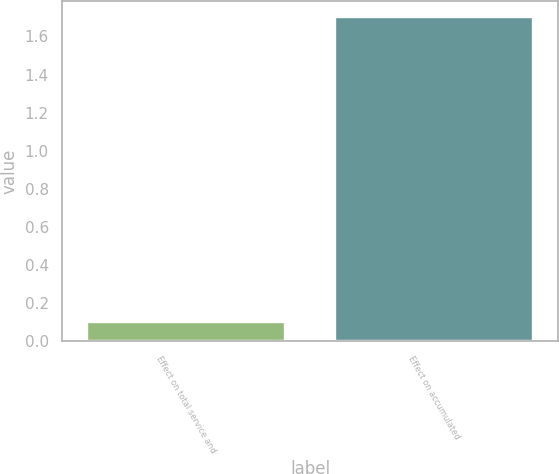Convert chart. <chart><loc_0><loc_0><loc_500><loc_500><bar_chart><fcel>Effect on total service and<fcel>Effect on accumulated<nl><fcel>0.1<fcel>1.7<nl></chart> 